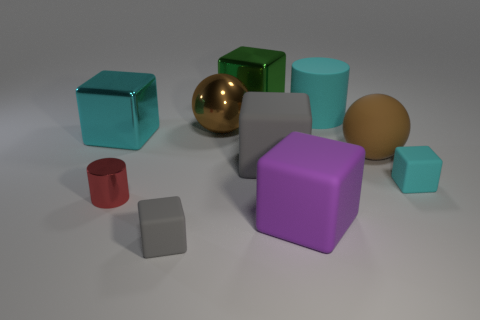How many tiny metallic cylinders are behind the big brown sphere right of the large cyan thing that is on the right side of the cyan metallic block?
Your response must be concise. 0. What color is the other thing that is the same shape as the brown metallic thing?
Ensure brevity in your answer.  Brown. What is the shape of the tiny thing on the right side of the gray thing that is on the left side of the metallic block on the right side of the red metallic cylinder?
Give a very brief answer. Cube. What is the size of the object that is both in front of the tiny cyan block and left of the small gray thing?
Make the answer very short. Small. Are there fewer tiny blocks than big gray matte things?
Your answer should be very brief. No. What is the size of the cyan metallic cube that is left of the tiny gray block?
Your answer should be very brief. Large. There is a big thing that is both to the right of the large cyan metal block and on the left side of the green object; what shape is it?
Provide a succinct answer. Sphere. What size is the cyan matte object that is the same shape as the tiny gray object?
Your answer should be very brief. Small. What number of tiny gray things have the same material as the green block?
Make the answer very short. 0. Is the color of the big rubber cylinder the same as the small cube on the right side of the shiny ball?
Your answer should be compact. Yes. 